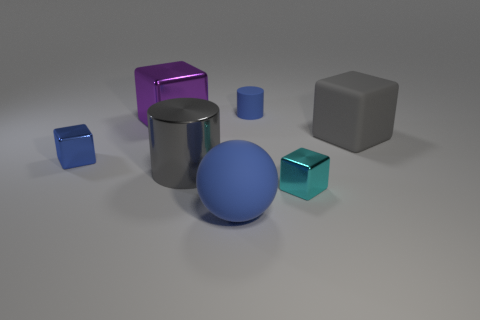The blue object that is the same material as the blue sphere is what size?
Ensure brevity in your answer.  Small. Is there any other thing that has the same color as the rubber cylinder?
Your answer should be compact. Yes. There is a big metal object that is in front of the large gray block; does it have the same color as the large matte thing on the right side of the tiny blue matte object?
Offer a very short reply. Yes. There is a rubber block that is behind the gray cylinder; what is its color?
Ensure brevity in your answer.  Gray. Do the blue matte object to the left of the rubber cylinder and the matte block have the same size?
Give a very brief answer. Yes. Are there fewer large metal cylinders than blue things?
Your answer should be compact. Yes. The thing that is the same color as the large cylinder is what shape?
Give a very brief answer. Cube. There is a cyan thing; how many cylinders are behind it?
Offer a very short reply. 2. Does the purple metal thing have the same shape as the blue metallic thing?
Give a very brief answer. Yes. What number of blue matte objects are both behind the big cylinder and in front of the cyan thing?
Offer a terse response. 0. 